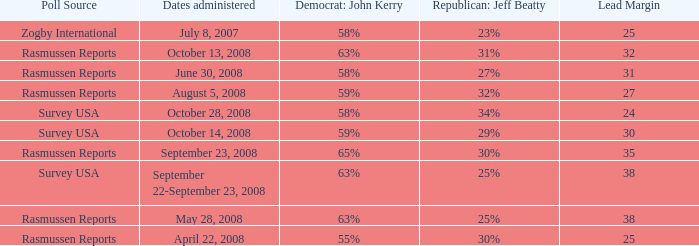Who is the poll source that has Republican: Jeff Beatty behind at 27%? Rasmussen Reports. 